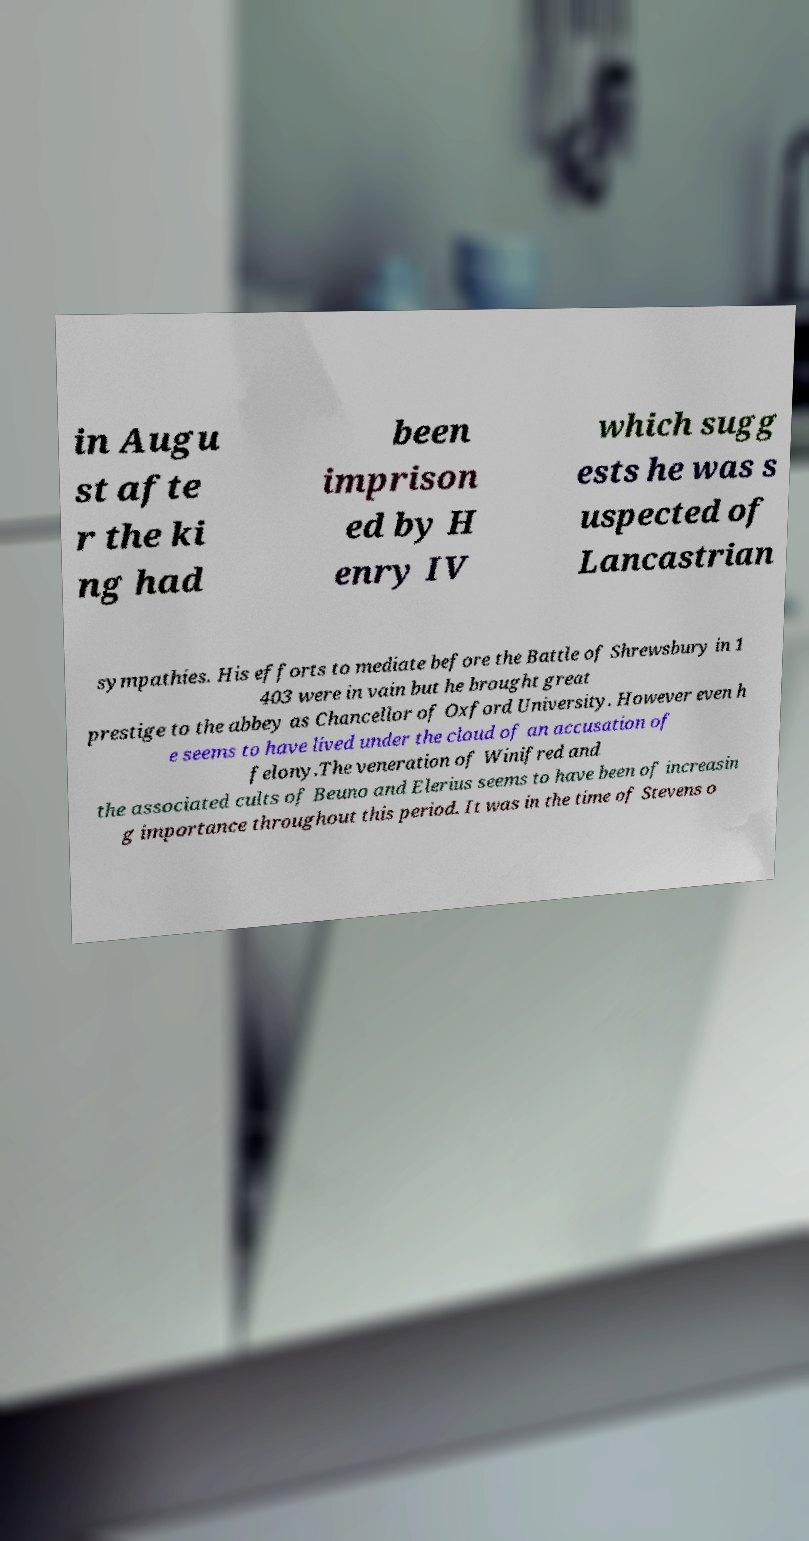Can you read and provide the text displayed in the image?This photo seems to have some interesting text. Can you extract and type it out for me? in Augu st afte r the ki ng had been imprison ed by H enry IV which sugg ests he was s uspected of Lancastrian sympathies. His efforts to mediate before the Battle of Shrewsbury in 1 403 were in vain but he brought great prestige to the abbey as Chancellor of Oxford University. However even h e seems to have lived under the cloud of an accusation of felony.The veneration of Winifred and the associated cults of Beuno and Elerius seems to have been of increasin g importance throughout this period. It was in the time of Stevens o 